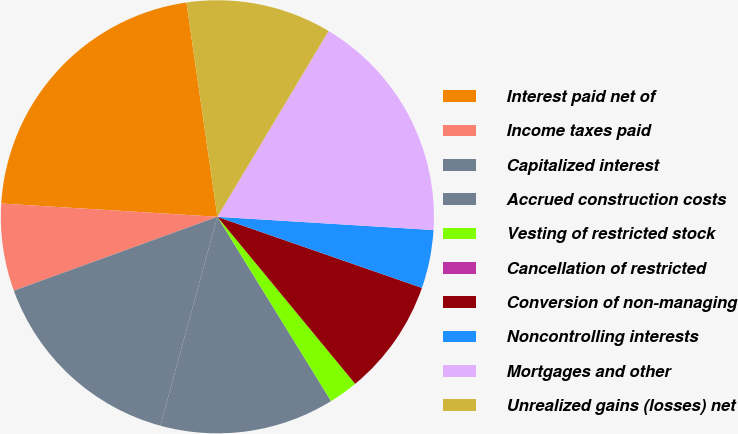Convert chart to OTSL. <chart><loc_0><loc_0><loc_500><loc_500><pie_chart><fcel>Interest paid net of<fcel>Income taxes paid<fcel>Capitalized interest<fcel>Accrued construction costs<fcel>Vesting of restricted stock<fcel>Cancellation of restricted<fcel>Conversion of non-managing<fcel>Noncontrolling interests<fcel>Mortgages and other<fcel>Unrealized gains (losses) net<nl><fcel>21.74%<fcel>6.52%<fcel>15.22%<fcel>13.04%<fcel>2.18%<fcel>0.0%<fcel>8.7%<fcel>4.35%<fcel>17.39%<fcel>10.87%<nl></chart> 